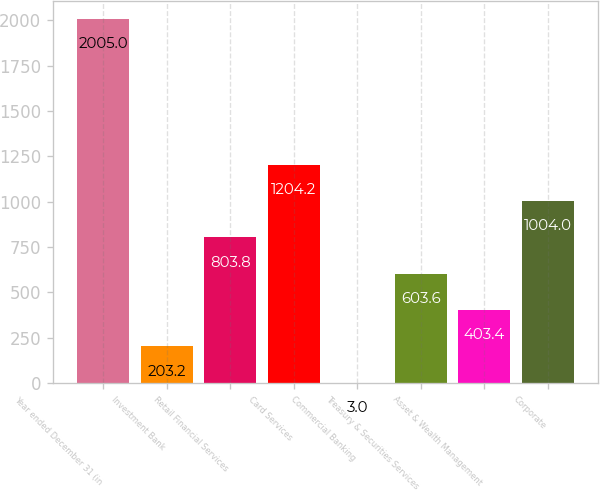Convert chart to OTSL. <chart><loc_0><loc_0><loc_500><loc_500><bar_chart><fcel>Year ended December 31 (in<fcel>Investment Bank<fcel>Retail Financial Services<fcel>Card Services<fcel>Commercial Banking<fcel>Treasury & Securities Services<fcel>Asset & Wealth Management<fcel>Corporate<nl><fcel>2005<fcel>203.2<fcel>803.8<fcel>1204.2<fcel>3<fcel>603.6<fcel>403.4<fcel>1004<nl></chart> 